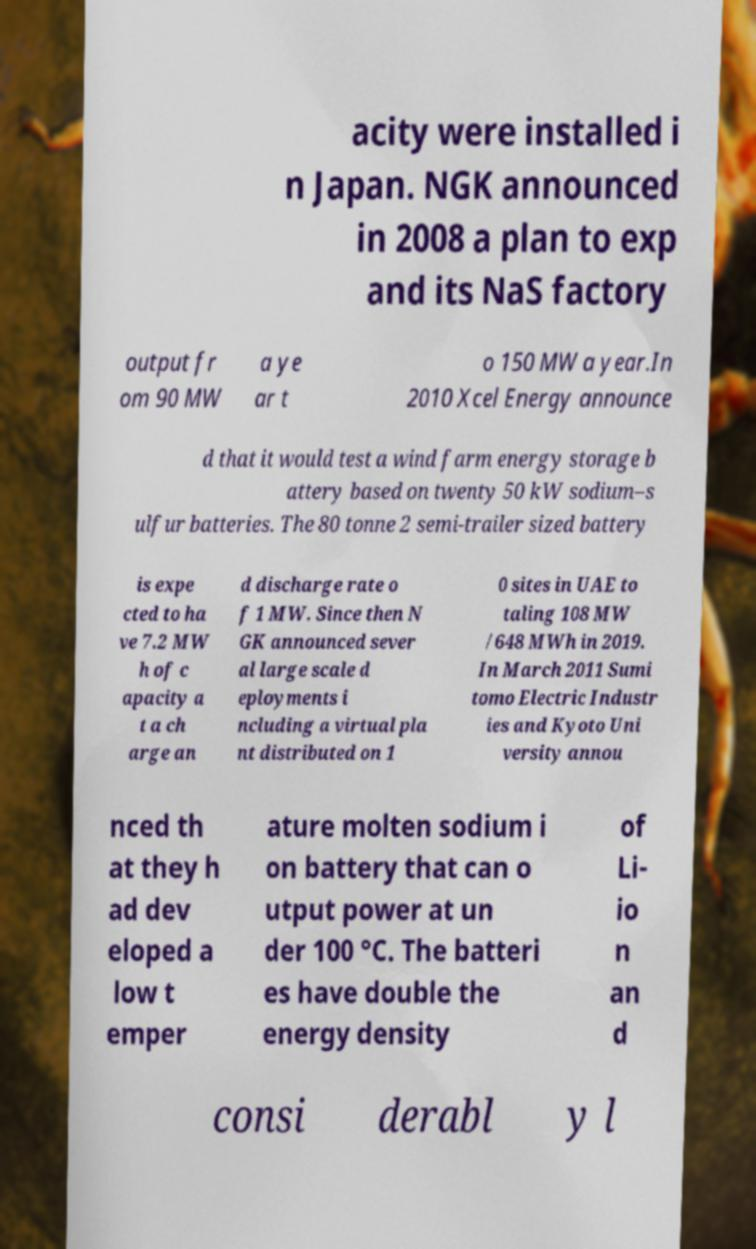Can you accurately transcribe the text from the provided image for me? acity were installed i n Japan. NGK announced in 2008 a plan to exp and its NaS factory output fr om 90 MW a ye ar t o 150 MW a year.In 2010 Xcel Energy announce d that it would test a wind farm energy storage b attery based on twenty 50 kW sodium–s ulfur batteries. The 80 tonne 2 semi-trailer sized battery is expe cted to ha ve 7.2 MW h of c apacity a t a ch arge an d discharge rate o f 1 MW. Since then N GK announced sever al large scale d eployments i ncluding a virtual pla nt distributed on 1 0 sites in UAE to taling 108 MW /648 MWh in 2019. In March 2011 Sumi tomo Electric Industr ies and Kyoto Uni versity annou nced th at they h ad dev eloped a low t emper ature molten sodium i on battery that can o utput power at un der 100 °C. The batteri es have double the energy density of Li- io n an d consi derabl y l 